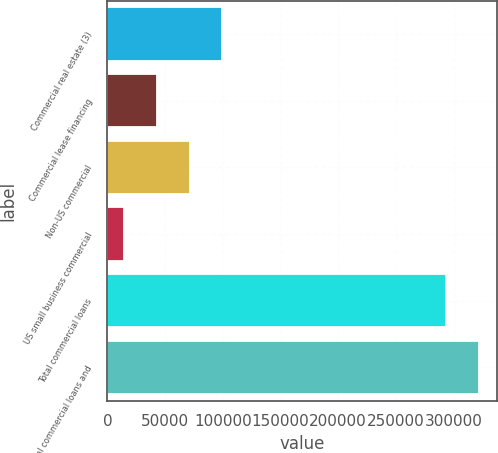Convert chart to OTSL. <chart><loc_0><loc_0><loc_500><loc_500><bar_chart><fcel>Commercial real estate (3)<fcel>Commercial lease financing<fcel>Non-US commercial<fcel>US small business commercial<fcel>Total commercial loans<fcel>Total commercial loans and<nl><fcel>99400.3<fcel>42946.1<fcel>71173.2<fcel>14719<fcel>293669<fcel>321896<nl></chart> 